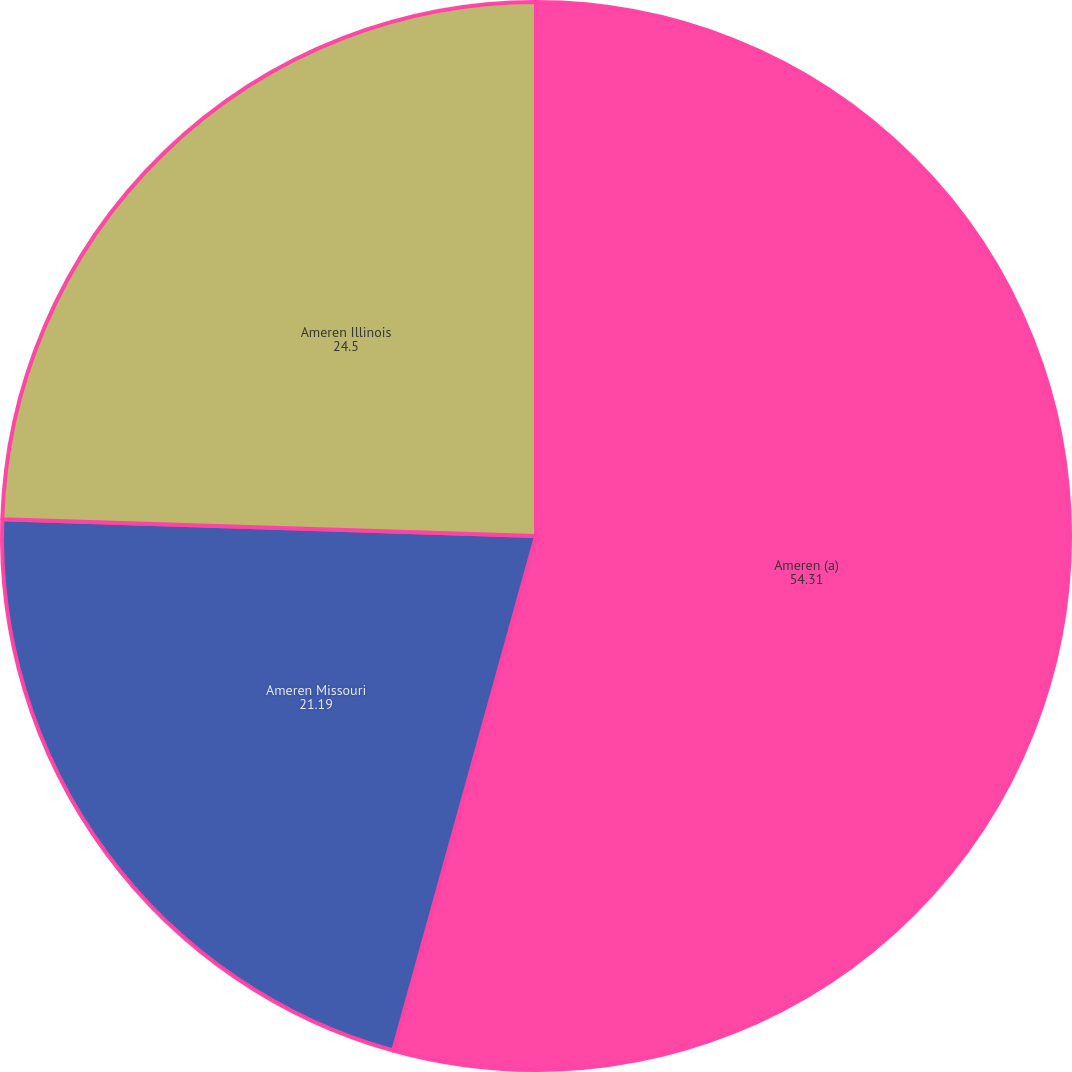Convert chart. <chart><loc_0><loc_0><loc_500><loc_500><pie_chart><fcel>Ameren (a)<fcel>Ameren Missouri<fcel>Ameren Illinois<nl><fcel>54.31%<fcel>21.19%<fcel>24.5%<nl></chart> 